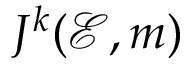<formula> <loc_0><loc_0><loc_500><loc_500>J ^ { k } ( { \mathcal { E } } , m )</formula> 